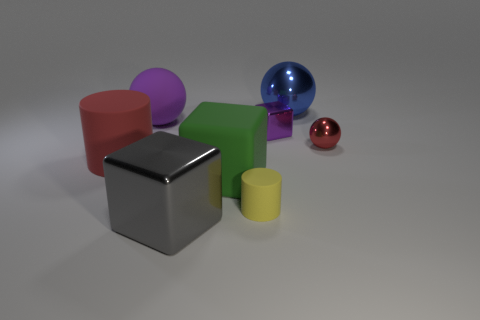Subtract all rubber balls. How many balls are left? 2 Add 1 blue shiny balls. How many objects exist? 9 Subtract all cylinders. How many objects are left? 6 Subtract 1 cylinders. How many cylinders are left? 1 Subtract 1 purple spheres. How many objects are left? 7 Subtract all green cylinders. Subtract all blue spheres. How many cylinders are left? 2 Subtract all gray cubes. Subtract all yellow rubber cylinders. How many objects are left? 6 Add 5 tiny balls. How many tiny balls are left? 6 Add 7 shiny blocks. How many shiny blocks exist? 9 